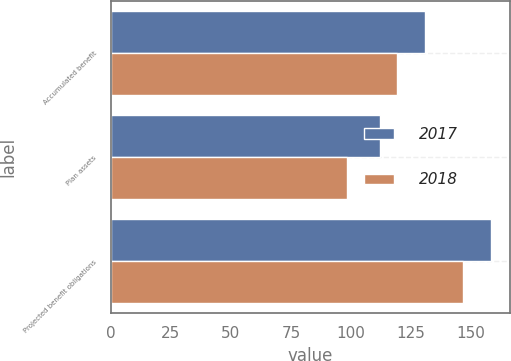<chart> <loc_0><loc_0><loc_500><loc_500><stacked_bar_chart><ecel><fcel>Accumulated benefit<fcel>Plan assets<fcel>Projected benefit obligations<nl><fcel>2017<fcel>130.7<fcel>112.1<fcel>158.1<nl><fcel>2018<fcel>119.2<fcel>98.3<fcel>146.4<nl></chart> 